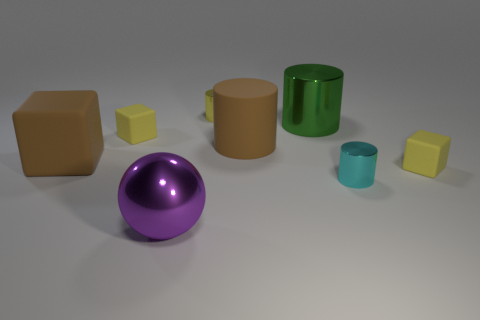Add 2 purple things. How many objects exist? 10 Subtract all balls. How many objects are left? 7 Add 6 big metallic cylinders. How many big metallic cylinders exist? 7 Subtract 1 cyan cylinders. How many objects are left? 7 Subtract all tiny brown matte cubes. Subtract all green shiny things. How many objects are left? 7 Add 4 tiny cylinders. How many tiny cylinders are left? 6 